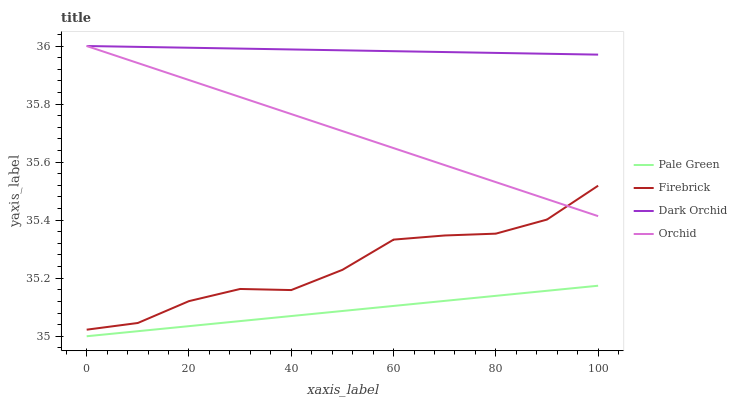Does Pale Green have the minimum area under the curve?
Answer yes or no. Yes. Does Dark Orchid have the maximum area under the curve?
Answer yes or no. Yes. Does Dark Orchid have the minimum area under the curve?
Answer yes or no. No. Does Pale Green have the maximum area under the curve?
Answer yes or no. No. Is Orchid the smoothest?
Answer yes or no. Yes. Is Firebrick the roughest?
Answer yes or no. Yes. Is Pale Green the smoothest?
Answer yes or no. No. Is Pale Green the roughest?
Answer yes or no. No. Does Pale Green have the lowest value?
Answer yes or no. Yes. Does Dark Orchid have the lowest value?
Answer yes or no. No. Does Orchid have the highest value?
Answer yes or no. Yes. Does Pale Green have the highest value?
Answer yes or no. No. Is Pale Green less than Orchid?
Answer yes or no. Yes. Is Dark Orchid greater than Firebrick?
Answer yes or no. Yes. Does Orchid intersect Dark Orchid?
Answer yes or no. Yes. Is Orchid less than Dark Orchid?
Answer yes or no. No. Is Orchid greater than Dark Orchid?
Answer yes or no. No. Does Pale Green intersect Orchid?
Answer yes or no. No. 